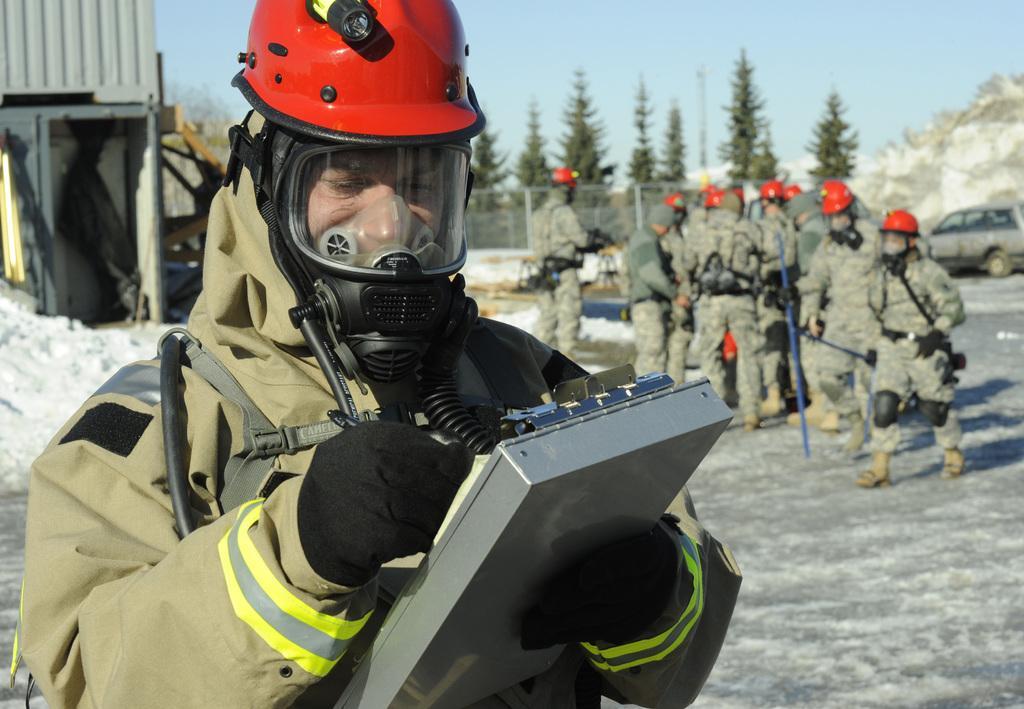How would you summarize this image in a sentence or two? This image is clicked outside. There are some persons in the middle. There are trees at the top. There is sky at the top. There is a car on the right side. All the people are wearing helmets and they are in military dresses. 